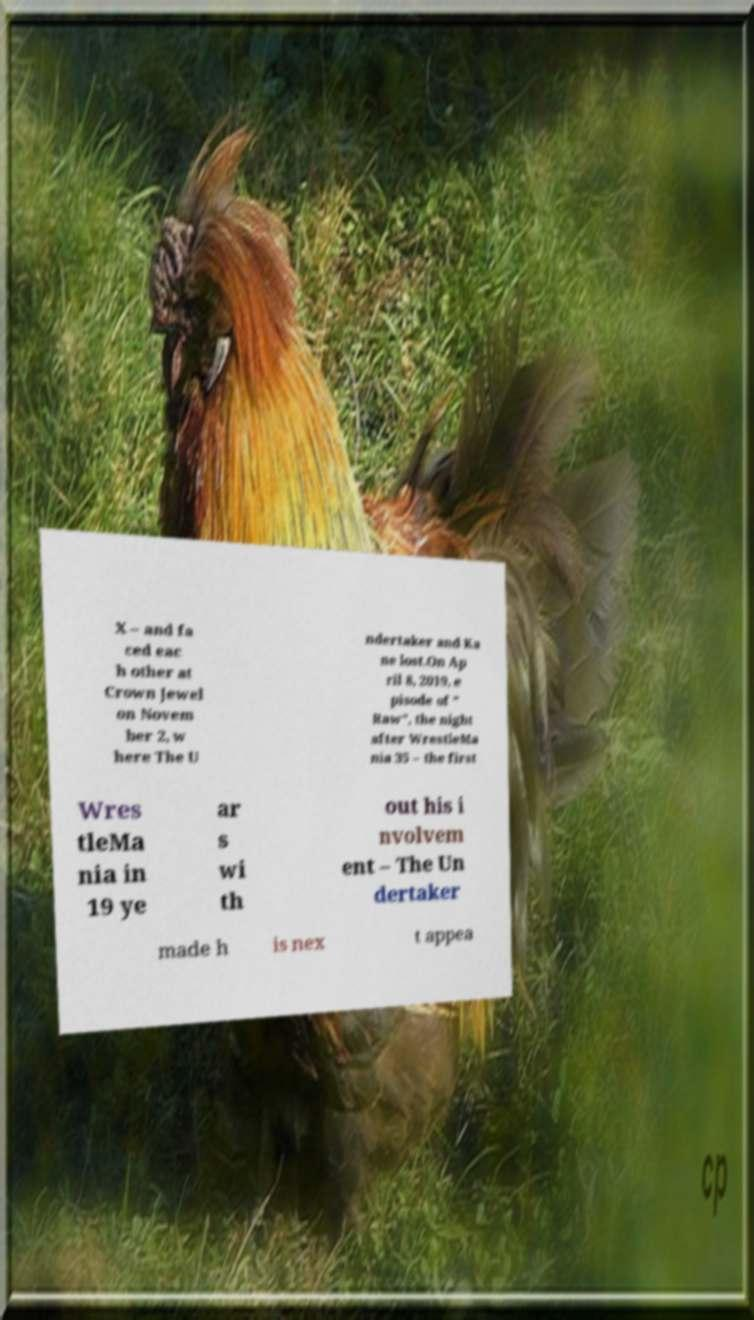Could you extract and type out the text from this image? X – and fa ced eac h other at Crown Jewel on Novem ber 2, w here The U ndertaker and Ka ne lost.On Ap ril 8, 2019, e pisode of " Raw", the night after WrestleMa nia 35 – the first Wres tleMa nia in 19 ye ar s wi th out his i nvolvem ent – The Un dertaker made h is nex t appea 